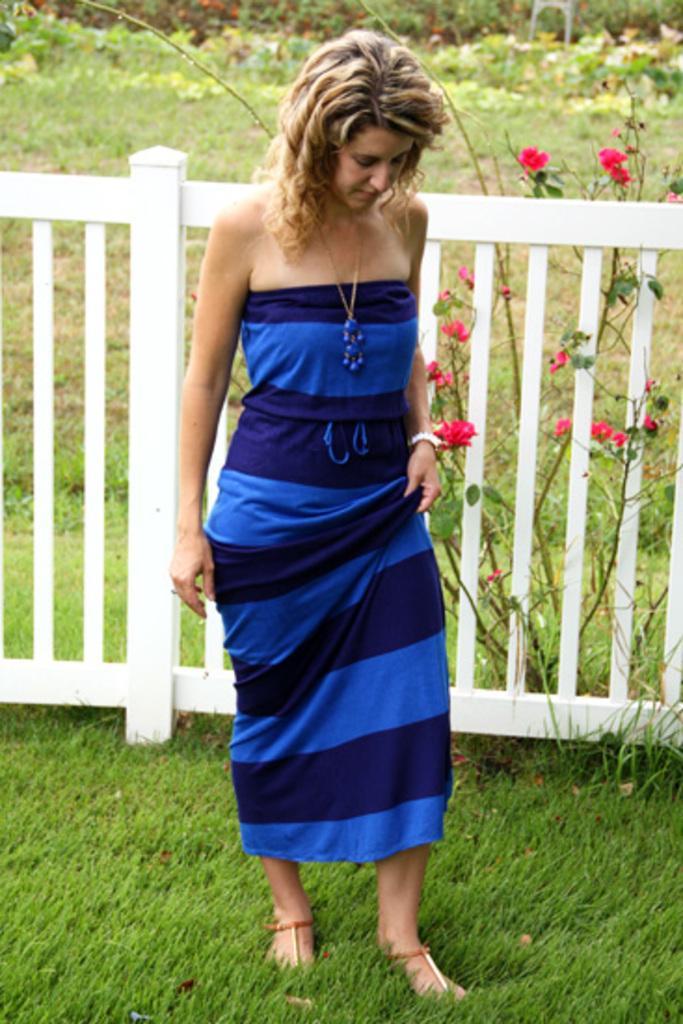Describe this image in one or two sentences. In this image I can see a woman wearing blue colored dress is standing on the ground. I can see the white colored fence, some grass and a plant with red colored flowers in the background. 